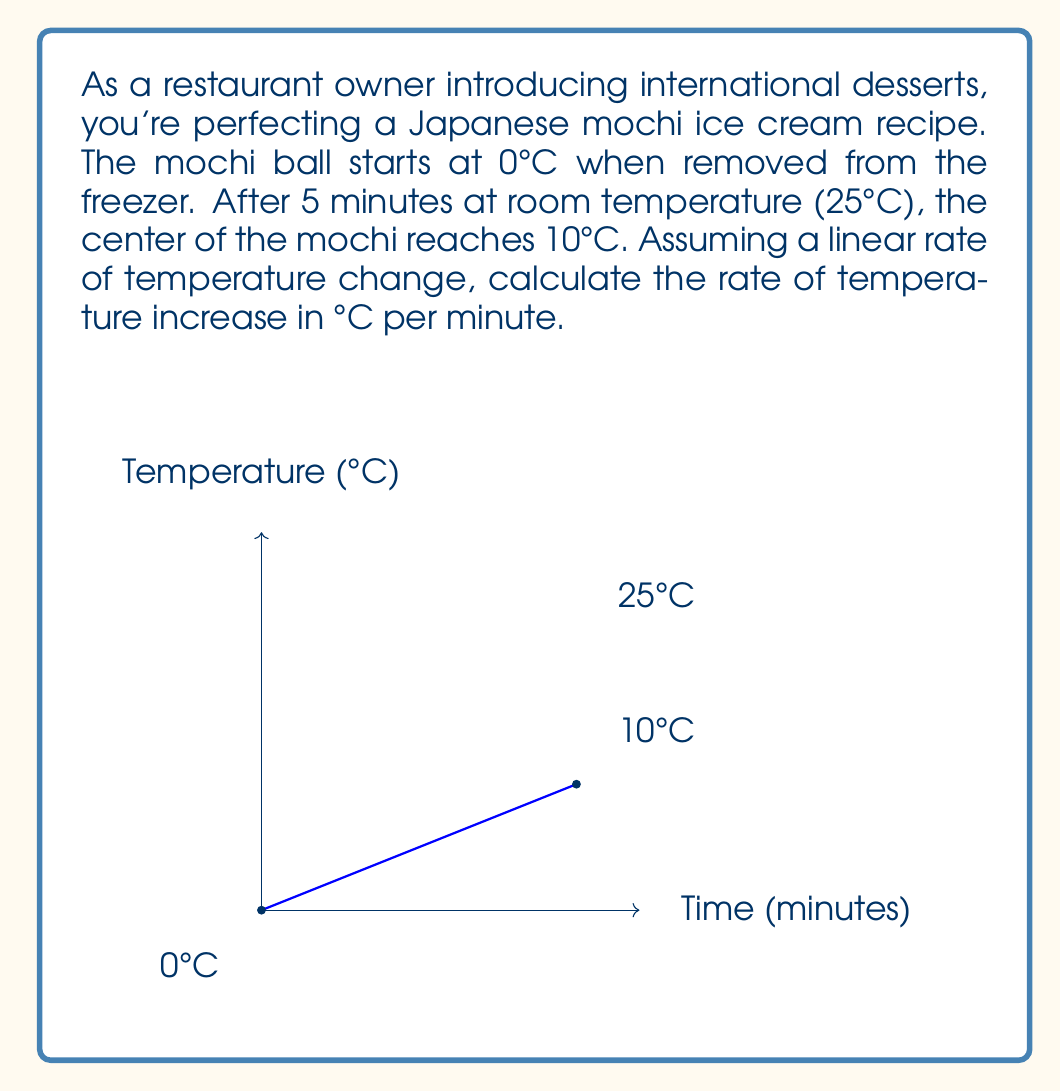Can you answer this question? Let's approach this step-by-step:

1) We need to find the rate of change, which is given by the formula:

   $$ \text{Rate of change} = \frac{\text{Change in temperature}}{\text{Change in time}} $$

2) From the given information:
   - Initial temperature: 0°C
   - Final temperature: 10°C
   - Time elapsed: 5 minutes

3) Let's calculate the change in temperature:
   $$ \Delta T = \text{Final temperature} - \text{Initial temperature} $$
   $$ \Delta T = 10°C - 0°C = 10°C $$

4) The change in time is given as 5 minutes.

5) Now, let's substitute these values into our rate of change formula:

   $$ \text{Rate of change} = \frac{10°C}{5 \text{ minutes}} $$

6) Simplify:
   $$ \text{Rate of change} = 2°C/\text{minute} $$

Therefore, the temperature of the mochi ice cream is increasing at a rate of 2°C per minute.
Answer: $2°C/\text{minute}$ 